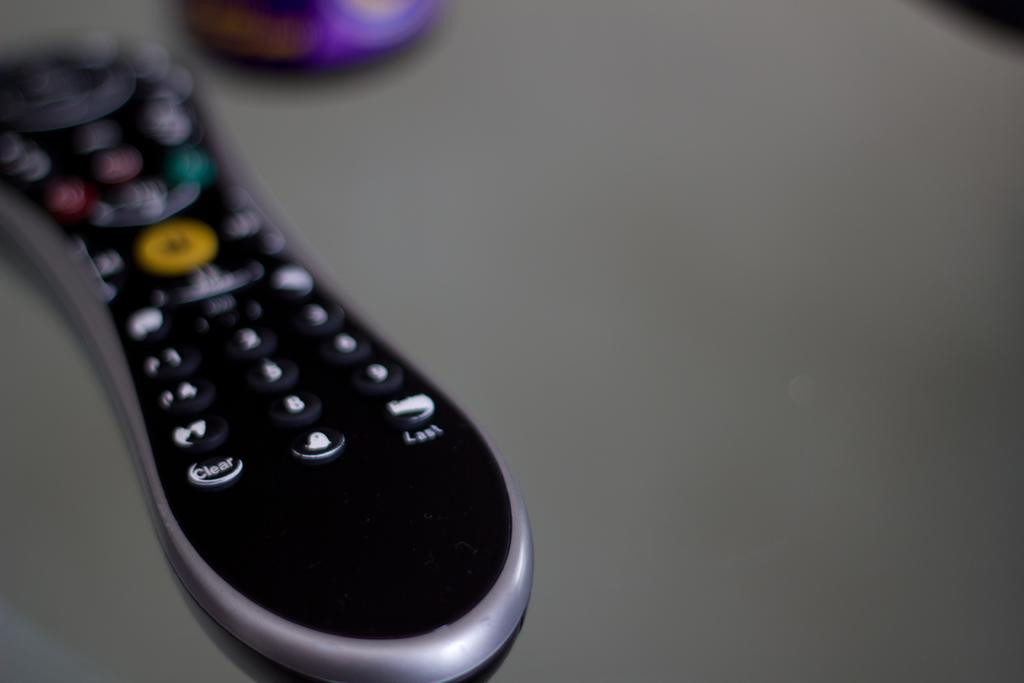<image>
Describe the image concisely. A bone shaped remote with many colored buttons, the bottom left one says clear. 